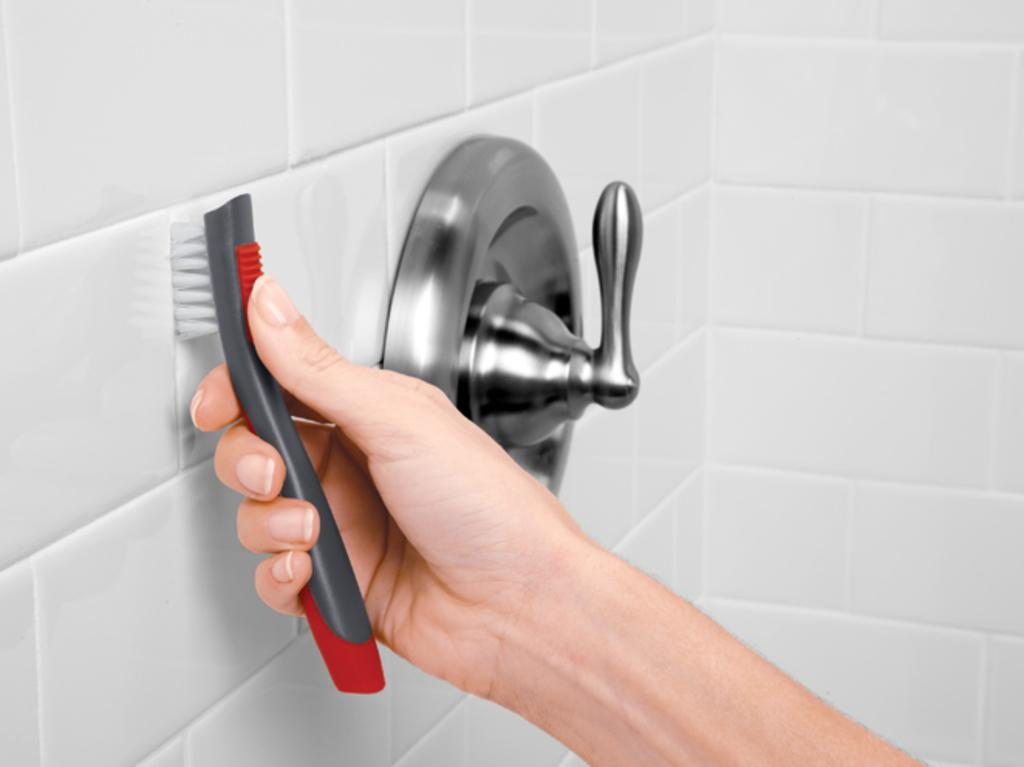What type of surface is shown in the image? The image shows a washroom wall. What color are the tiles on the wall? The wall has white color tiles. What can be seen in the person's hand in the image? There is a person's hand with a brush in the image. What is the person's hand doing with the brush? The person's hand is pressing the brush against the wall. What is attached to the wall in the image? There is a tap handle on the wall in the image. What type of insurance policy is being discussed in the image? There is no discussion of insurance in the image; it shows a washroom wall with a person's hand pressing a brush against it. Can you see a guitar in the image? No, there is no guitar present in the image. 